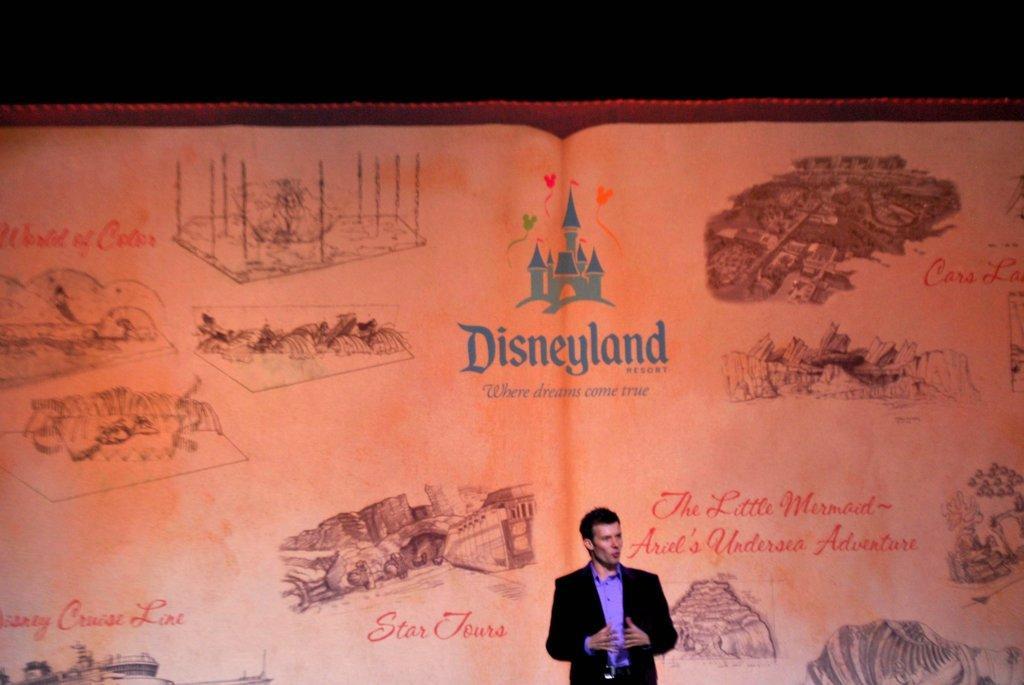Can you describe this image briefly? In this image, we can see a person who is wearing some clothes and he is talking. In the background, we can see a screen with some pictures and text printed on it. 